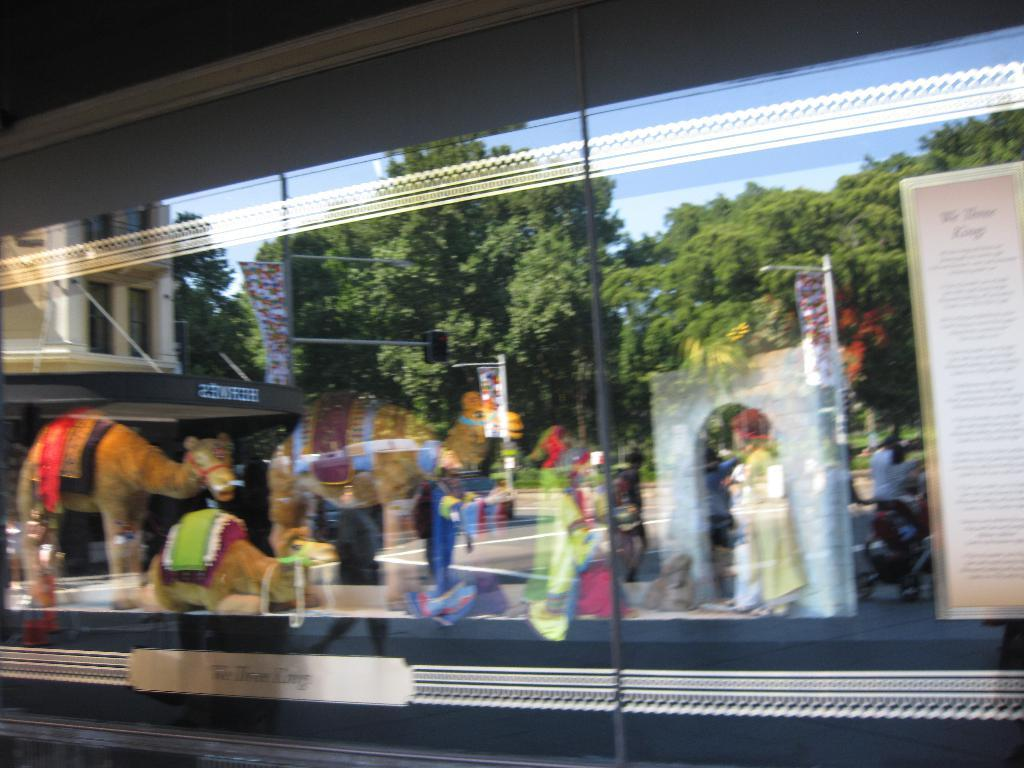What type of toys are present in the image? There are toys of camels in the image. What other items can be seen in the image besides the toys? There are other items in the image, but their specific nature is not mentioned in the provided facts. What is reflected in the image? There is a reflection of a building in the image. Who or what is visible in the image? There is a group of people visible in the image. What type of man-made structure can be seen in the image? There is a road in the image. What type of natural elements are present in the image? There are trees in the image. What part of the natural environment is visible in the image? The sky is visible in the image. What time of day is it in the image, and is there a pencil visible? The provided facts do not mention the time of day, and there is no mention of a pencil being present in the image. 